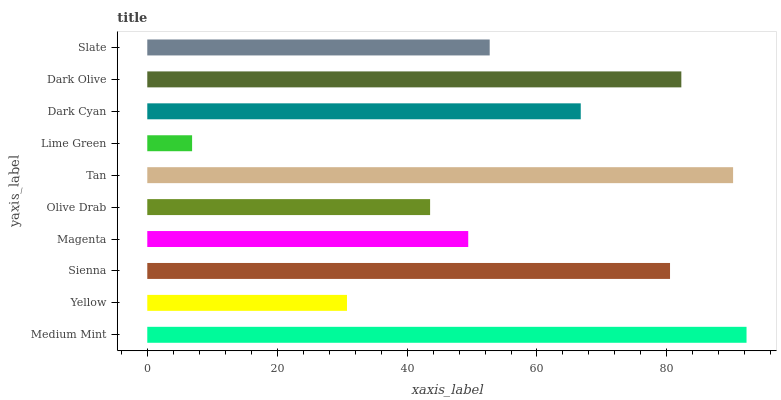Is Lime Green the minimum?
Answer yes or no. Yes. Is Medium Mint the maximum?
Answer yes or no. Yes. Is Yellow the minimum?
Answer yes or no. No. Is Yellow the maximum?
Answer yes or no. No. Is Medium Mint greater than Yellow?
Answer yes or no. Yes. Is Yellow less than Medium Mint?
Answer yes or no. Yes. Is Yellow greater than Medium Mint?
Answer yes or no. No. Is Medium Mint less than Yellow?
Answer yes or no. No. Is Dark Cyan the high median?
Answer yes or no. Yes. Is Slate the low median?
Answer yes or no. Yes. Is Sienna the high median?
Answer yes or no. No. Is Medium Mint the low median?
Answer yes or no. No. 